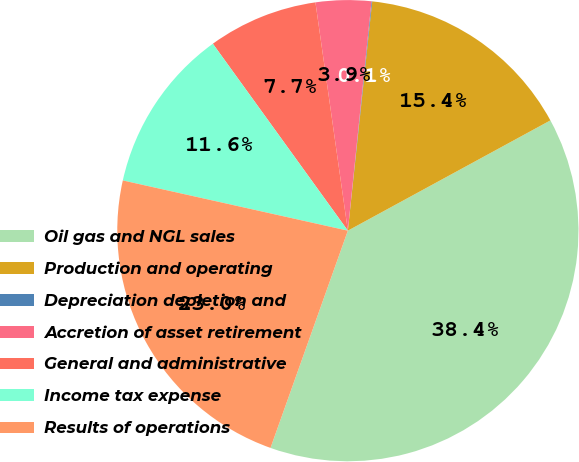Convert chart. <chart><loc_0><loc_0><loc_500><loc_500><pie_chart><fcel>Oil gas and NGL sales<fcel>Production and operating<fcel>Depreciation depletion and<fcel>Accretion of asset retirement<fcel>General and administrative<fcel>Income tax expense<fcel>Results of operations<nl><fcel>38.38%<fcel>15.38%<fcel>0.05%<fcel>3.88%<fcel>7.71%<fcel>11.55%<fcel>23.05%<nl></chart> 